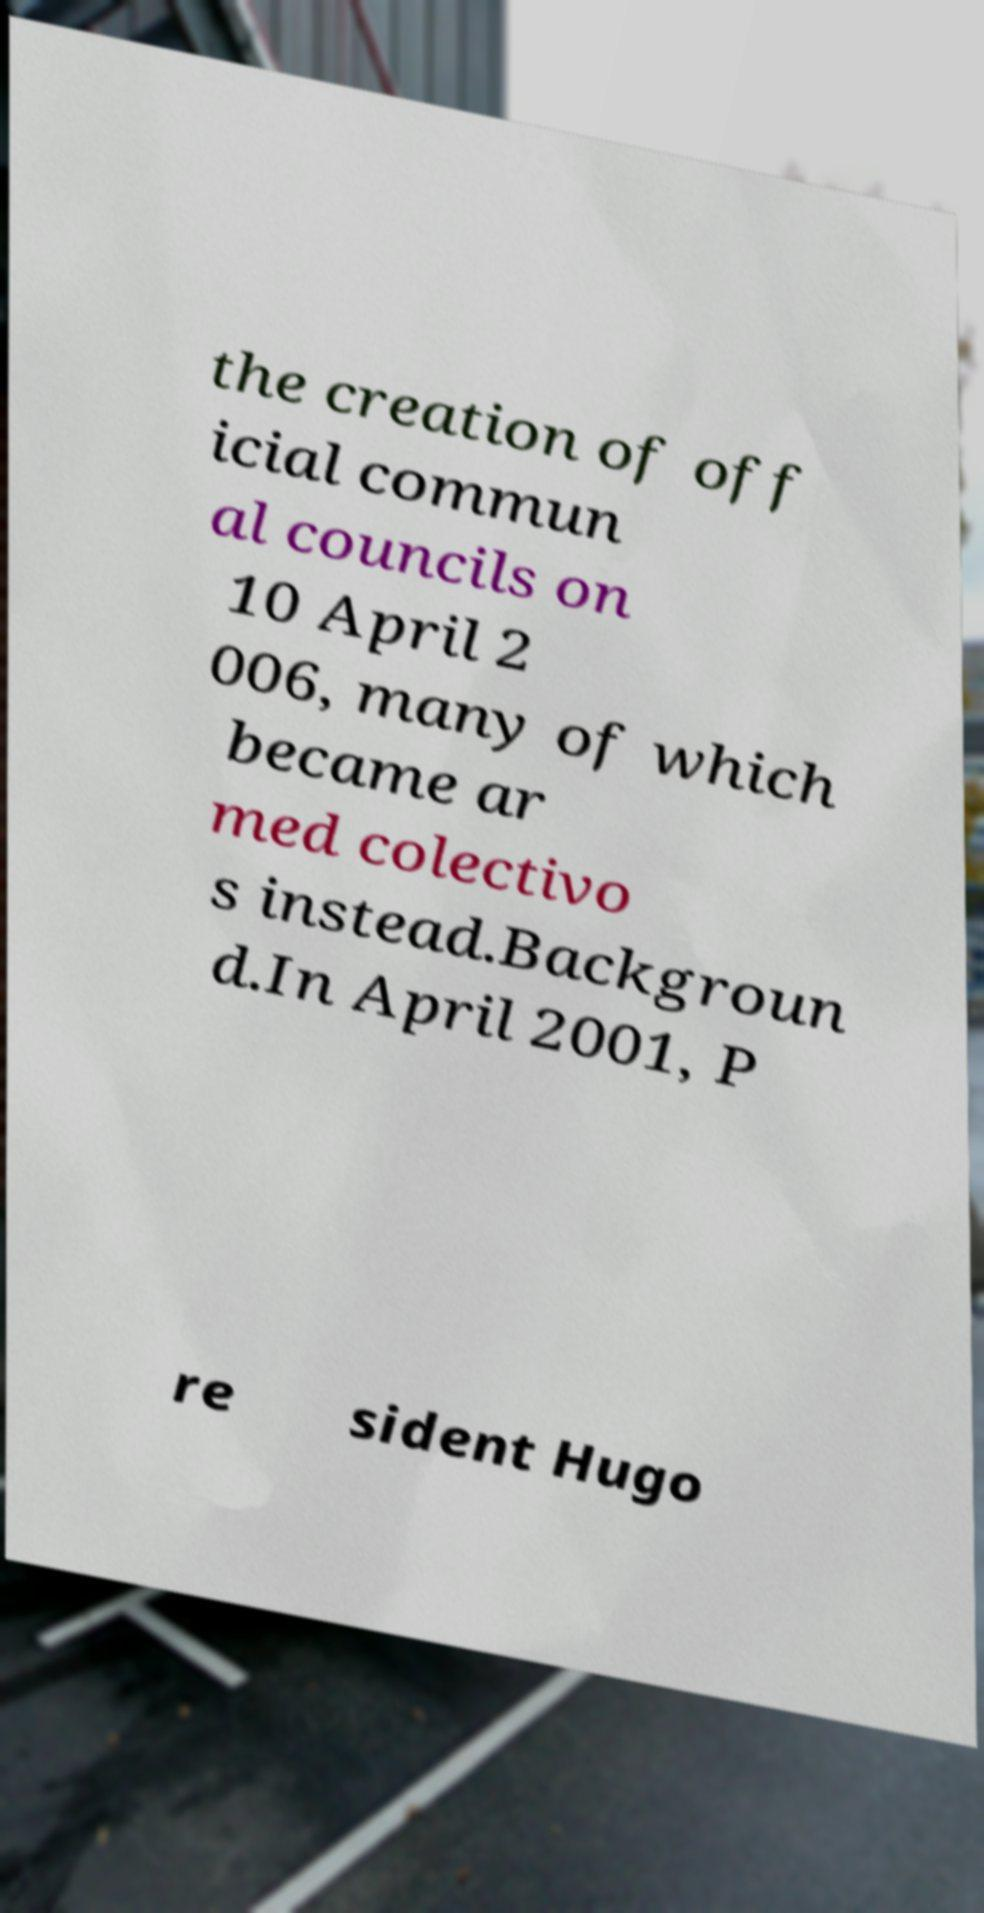Could you assist in decoding the text presented in this image and type it out clearly? the creation of off icial commun al councils on 10 April 2 006, many of which became ar med colectivo s instead.Backgroun d.In April 2001, P re sident Hugo 